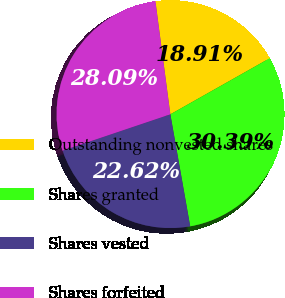Convert chart. <chart><loc_0><loc_0><loc_500><loc_500><pie_chart><fcel>Outstanding nonvested shares<fcel>Shares granted<fcel>Shares vested<fcel>Shares forfeited<nl><fcel>18.91%<fcel>30.39%<fcel>22.62%<fcel>28.09%<nl></chart> 